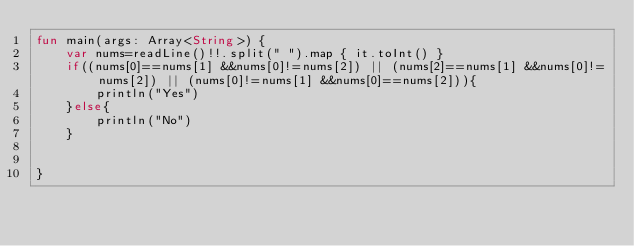<code> <loc_0><loc_0><loc_500><loc_500><_Kotlin_>fun main(args: Array<String>) {
    var nums=readLine()!!.split(" ").map { it.toInt() }
    if((nums[0]==nums[1] &&nums[0]!=nums[2]) || (nums[2]==nums[1] &&nums[0]!=nums[2]) || (nums[0]!=nums[1] &&nums[0]==nums[2])){
        println("Yes")
    }else{
        println("No")
    }


}</code> 